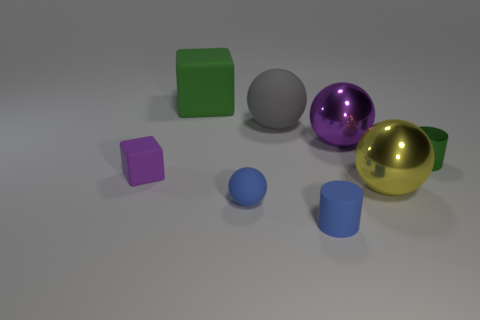Subtract all green blocks. How many blocks are left? 1 Subtract all big purple metal spheres. How many spheres are left? 3 Subtract all cubes. How many objects are left? 6 Subtract 1 blocks. How many blocks are left? 1 Subtract all gray cylinders. Subtract all yellow blocks. How many cylinders are left? 2 Subtract all green blocks. How many green cylinders are left? 1 Subtract all tiny blue cylinders. Subtract all cubes. How many objects are left? 5 Add 4 large blocks. How many large blocks are left? 5 Add 7 green cylinders. How many green cylinders exist? 8 Add 1 gray shiny spheres. How many objects exist? 9 